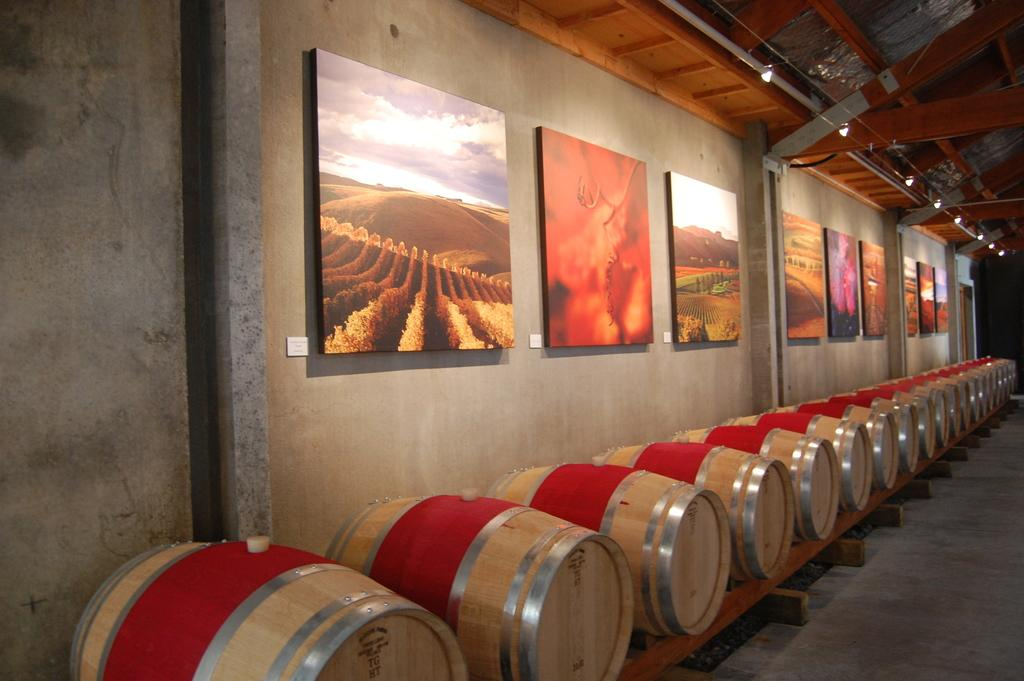What is hanging on the wall in the image? There are frames on the wall in the image. What can be seen arranged in a line in the image? There are containers arranged in a line in the image. What type of grass is growing in the image? There is no grass present in the image. What position does the rake hold in the image? There is no rake present in the image. 